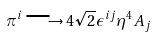<formula> <loc_0><loc_0><loc_500><loc_500>\pi ^ { i } \longrightarrow 4 \sqrt { 2 } \epsilon ^ { i j } \eta ^ { 4 } A _ { j }</formula> 